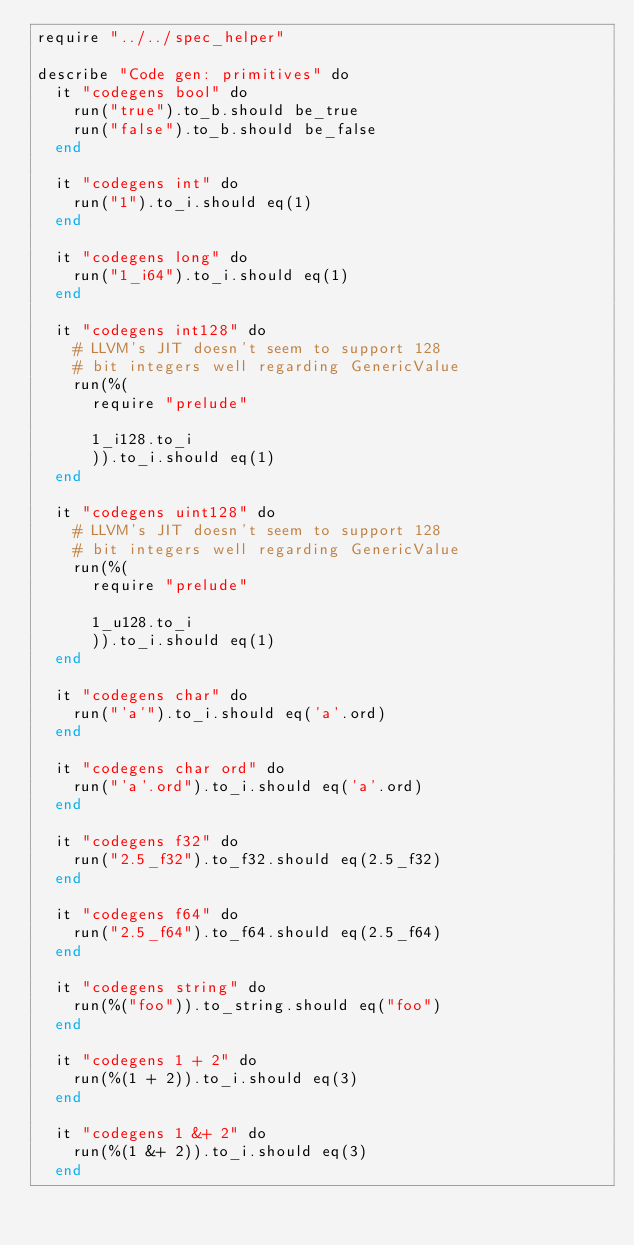Convert code to text. <code><loc_0><loc_0><loc_500><loc_500><_Crystal_>require "../../spec_helper"

describe "Code gen: primitives" do
  it "codegens bool" do
    run("true").to_b.should be_true
    run("false").to_b.should be_false
  end

  it "codegens int" do
    run("1").to_i.should eq(1)
  end

  it "codegens long" do
    run("1_i64").to_i.should eq(1)
  end

  it "codegens int128" do
    # LLVM's JIT doesn't seem to support 128
    # bit integers well regarding GenericValue
    run(%(
      require "prelude"

      1_i128.to_i
      )).to_i.should eq(1)
  end

  it "codegens uint128" do
    # LLVM's JIT doesn't seem to support 128
    # bit integers well regarding GenericValue
    run(%(
      require "prelude"

      1_u128.to_i
      )).to_i.should eq(1)
  end

  it "codegens char" do
    run("'a'").to_i.should eq('a'.ord)
  end

  it "codegens char ord" do
    run("'a'.ord").to_i.should eq('a'.ord)
  end

  it "codegens f32" do
    run("2.5_f32").to_f32.should eq(2.5_f32)
  end

  it "codegens f64" do
    run("2.5_f64").to_f64.should eq(2.5_f64)
  end

  it "codegens string" do
    run(%("foo")).to_string.should eq("foo")
  end

  it "codegens 1 + 2" do
    run(%(1 + 2)).to_i.should eq(3)
  end

  it "codegens 1 &+ 2" do
    run(%(1 &+ 2)).to_i.should eq(3)
  end
</code> 